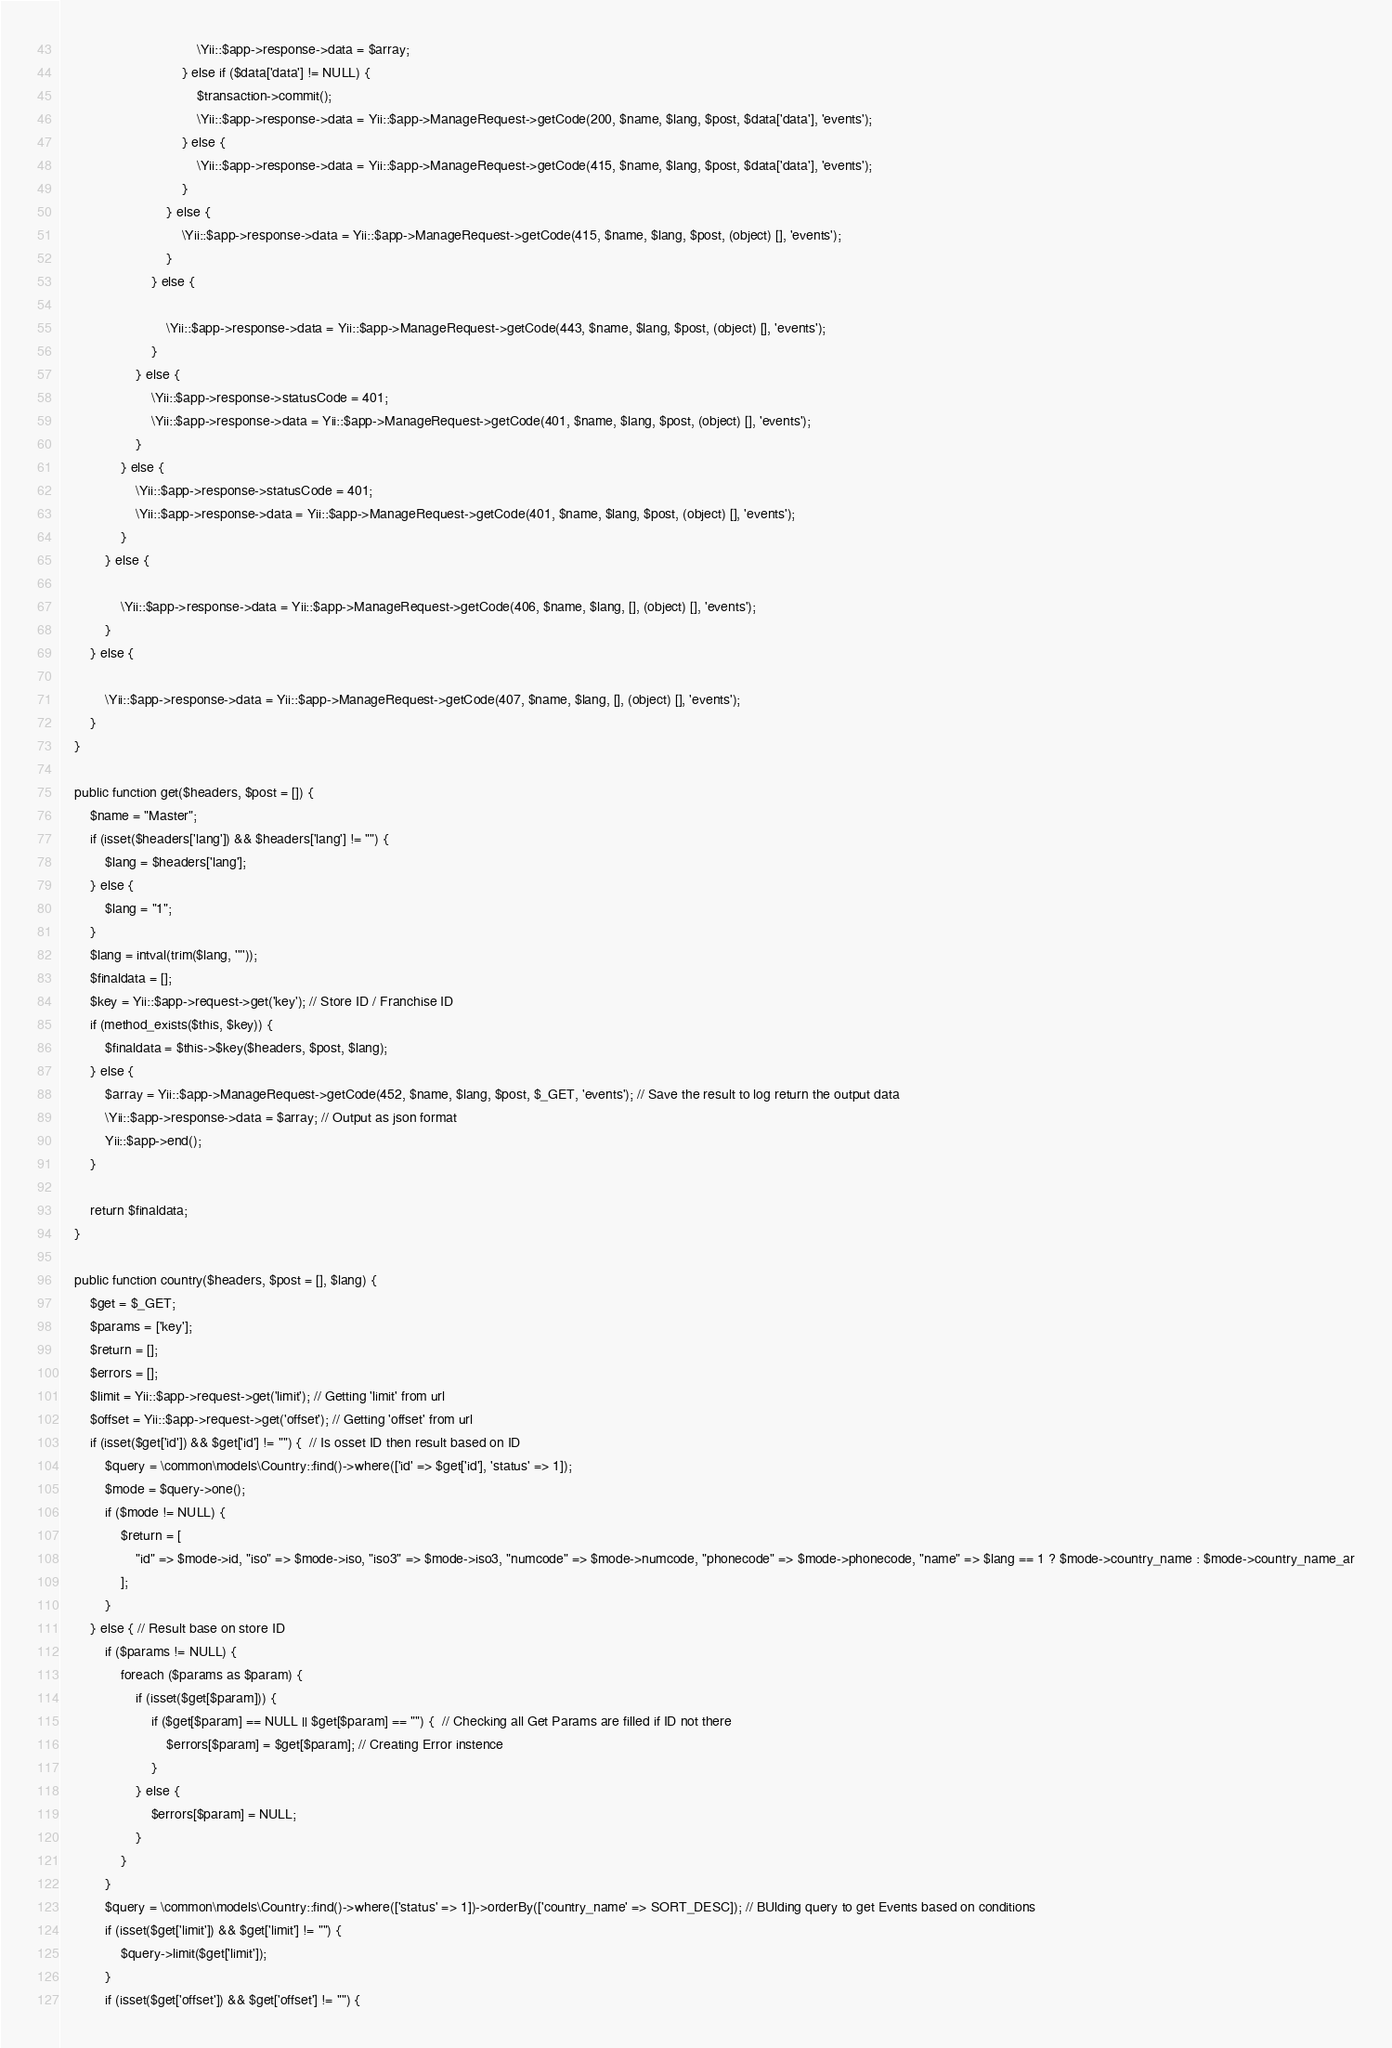Convert code to text. <code><loc_0><loc_0><loc_500><loc_500><_PHP_>                                    \Yii::$app->response->data = $array;
                                } else if ($data['data'] != NULL) {
                                    $transaction->commit();
                                    \Yii::$app->response->data = Yii::$app->ManageRequest->getCode(200, $name, $lang, $post, $data['data'], 'events');
                                } else {
                                    \Yii::$app->response->data = Yii::$app->ManageRequest->getCode(415, $name, $lang, $post, $data['data'], 'events');
                                }
                            } else {
                                \Yii::$app->response->data = Yii::$app->ManageRequest->getCode(415, $name, $lang, $post, (object) [], 'events');
                            }
                        } else {

                            \Yii::$app->response->data = Yii::$app->ManageRequest->getCode(443, $name, $lang, $post, (object) [], 'events');
                        }
                    } else {
                        \Yii::$app->response->statusCode = 401;
                        \Yii::$app->response->data = Yii::$app->ManageRequest->getCode(401, $name, $lang, $post, (object) [], 'events');
                    }
                } else {
                    \Yii::$app->response->statusCode = 401;
                    \Yii::$app->response->data = Yii::$app->ManageRequest->getCode(401, $name, $lang, $post, (object) [], 'events');
                }
            } else {

                \Yii::$app->response->data = Yii::$app->ManageRequest->getCode(406, $name, $lang, [], (object) [], 'events');
            }
        } else {

            \Yii::$app->response->data = Yii::$app->ManageRequest->getCode(407, $name, $lang, [], (object) [], 'events');
        }
    }

    public function get($headers, $post = []) {
        $name = "Master";
        if (isset($headers['lang']) && $headers['lang'] != "") {
            $lang = $headers['lang'];
        } else {
            $lang = "1";
        }
        $lang = intval(trim($lang, '"'));
        $finaldata = [];
        $key = Yii::$app->request->get('key'); // Store ID / Franchise ID
        if (method_exists($this, $key)) {
            $finaldata = $this->$key($headers, $post, $lang);
        } else {
            $array = Yii::$app->ManageRequest->getCode(452, $name, $lang, $post, $_GET, 'events'); // Save the result to log return the output data
            \Yii::$app->response->data = $array; // Output as json format
            Yii::$app->end();
        }

        return $finaldata;
    }

    public function country($headers, $post = [], $lang) {
        $get = $_GET;
        $params = ['key'];
        $return = [];
        $errors = [];
        $limit = Yii::$app->request->get('limit'); // Getting 'limit' from url
        $offset = Yii::$app->request->get('offset'); // Getting 'offset' from url
        if (isset($get['id']) && $get['id'] != "") {  // Is osset ID then result based on ID
            $query = \common\models\Country::find()->where(['id' => $get['id'], 'status' => 1]);
            $mode = $query->one();
            if ($mode != NULL) {
                $return = [
                    "id" => $mode->id, "iso" => $mode->iso, "iso3" => $mode->iso3, "numcode" => $mode->numcode, "phonecode" => $mode->phonecode, "name" => $lang == 1 ? $mode->country_name : $mode->country_name_ar
                ];
            }
        } else { // Result base on store ID
            if ($params != NULL) {
                foreach ($params as $param) {
                    if (isset($get[$param])) {
                        if ($get[$param] == NULL || $get[$param] == "") {  // Checking all Get Params are filled if ID not there
                            $errors[$param] = $get[$param]; // Creating Error instence
                        }
                    } else {
                        $errors[$param] = NULL;
                    }
                }
            }
            $query = \common\models\Country::find()->where(['status' => 1])->orderBy(['country_name' => SORT_DESC]); // BUlding query to get Events based on conditions
            if (isset($get['limit']) && $get['limit'] != "") {
                $query->limit($get['limit']);
            }
            if (isset($get['offset']) && $get['offset'] != "") {</code> 